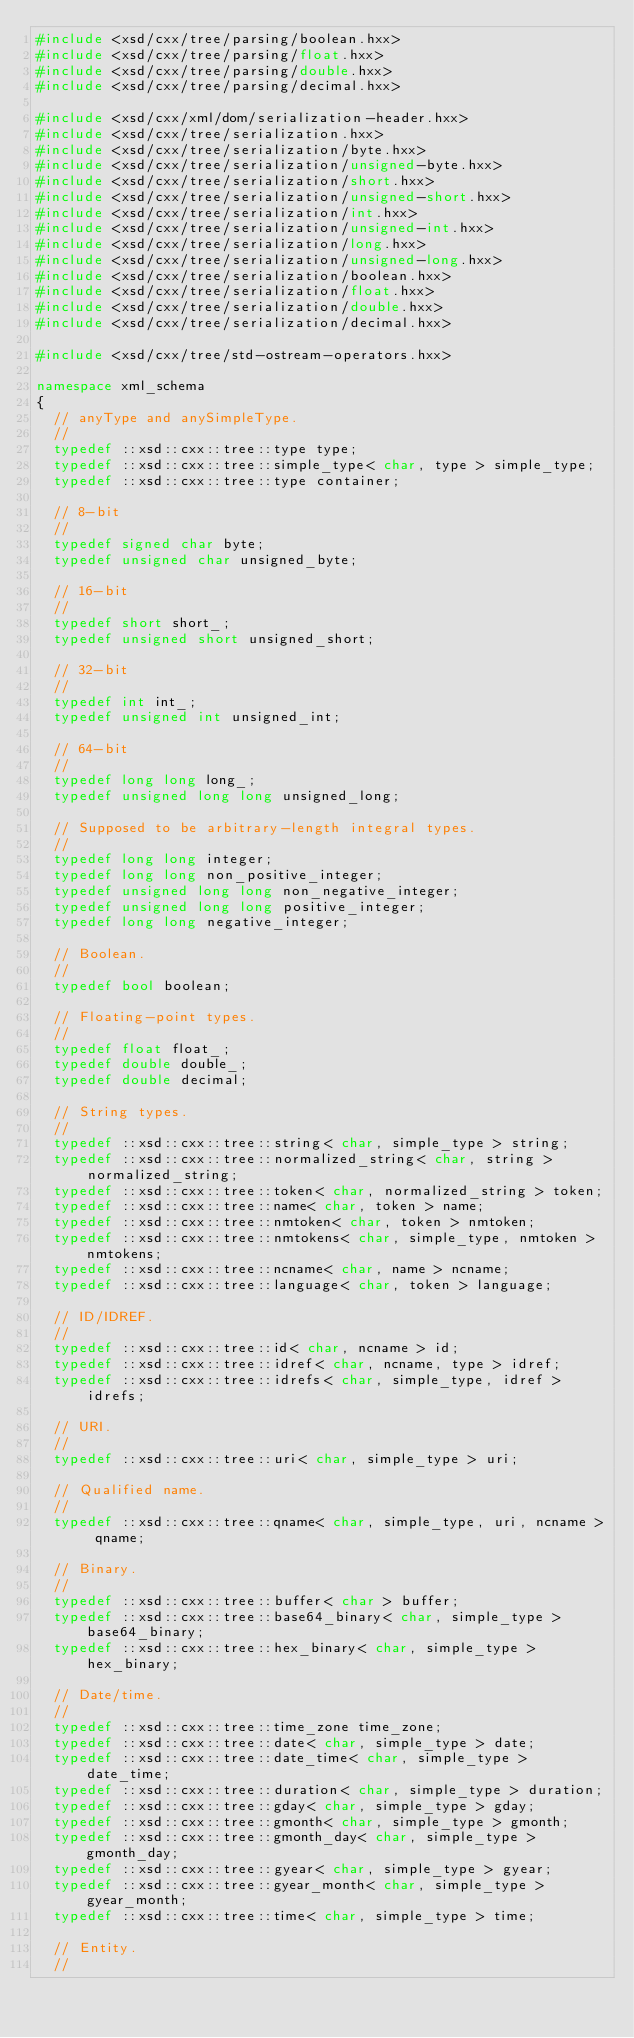Convert code to text. <code><loc_0><loc_0><loc_500><loc_500><_C++_>#include <xsd/cxx/tree/parsing/boolean.hxx>
#include <xsd/cxx/tree/parsing/float.hxx>
#include <xsd/cxx/tree/parsing/double.hxx>
#include <xsd/cxx/tree/parsing/decimal.hxx>

#include <xsd/cxx/xml/dom/serialization-header.hxx>
#include <xsd/cxx/tree/serialization.hxx>
#include <xsd/cxx/tree/serialization/byte.hxx>
#include <xsd/cxx/tree/serialization/unsigned-byte.hxx>
#include <xsd/cxx/tree/serialization/short.hxx>
#include <xsd/cxx/tree/serialization/unsigned-short.hxx>
#include <xsd/cxx/tree/serialization/int.hxx>
#include <xsd/cxx/tree/serialization/unsigned-int.hxx>
#include <xsd/cxx/tree/serialization/long.hxx>
#include <xsd/cxx/tree/serialization/unsigned-long.hxx>
#include <xsd/cxx/tree/serialization/boolean.hxx>
#include <xsd/cxx/tree/serialization/float.hxx>
#include <xsd/cxx/tree/serialization/double.hxx>
#include <xsd/cxx/tree/serialization/decimal.hxx>

#include <xsd/cxx/tree/std-ostream-operators.hxx>

namespace xml_schema
{
  // anyType and anySimpleType.
  //
  typedef ::xsd::cxx::tree::type type;
  typedef ::xsd::cxx::tree::simple_type< char, type > simple_type;
  typedef ::xsd::cxx::tree::type container;

  // 8-bit
  //
  typedef signed char byte;
  typedef unsigned char unsigned_byte;

  // 16-bit
  //
  typedef short short_;
  typedef unsigned short unsigned_short;

  // 32-bit
  //
  typedef int int_;
  typedef unsigned int unsigned_int;

  // 64-bit
  //
  typedef long long long_;
  typedef unsigned long long unsigned_long;

  // Supposed to be arbitrary-length integral types.
  //
  typedef long long integer;
  typedef long long non_positive_integer;
  typedef unsigned long long non_negative_integer;
  typedef unsigned long long positive_integer;
  typedef long long negative_integer;

  // Boolean.
  //
  typedef bool boolean;

  // Floating-point types.
  //
  typedef float float_;
  typedef double double_;
  typedef double decimal;

  // String types.
  //
  typedef ::xsd::cxx::tree::string< char, simple_type > string;
  typedef ::xsd::cxx::tree::normalized_string< char, string > normalized_string;
  typedef ::xsd::cxx::tree::token< char, normalized_string > token;
  typedef ::xsd::cxx::tree::name< char, token > name;
  typedef ::xsd::cxx::tree::nmtoken< char, token > nmtoken;
  typedef ::xsd::cxx::tree::nmtokens< char, simple_type, nmtoken > nmtokens;
  typedef ::xsd::cxx::tree::ncname< char, name > ncname;
  typedef ::xsd::cxx::tree::language< char, token > language;

  // ID/IDREF.
  //
  typedef ::xsd::cxx::tree::id< char, ncname > id;
  typedef ::xsd::cxx::tree::idref< char, ncname, type > idref;
  typedef ::xsd::cxx::tree::idrefs< char, simple_type, idref > idrefs;

  // URI.
  //
  typedef ::xsd::cxx::tree::uri< char, simple_type > uri;

  // Qualified name.
  //
  typedef ::xsd::cxx::tree::qname< char, simple_type, uri, ncname > qname;

  // Binary.
  //
  typedef ::xsd::cxx::tree::buffer< char > buffer;
  typedef ::xsd::cxx::tree::base64_binary< char, simple_type > base64_binary;
  typedef ::xsd::cxx::tree::hex_binary< char, simple_type > hex_binary;

  // Date/time.
  //
  typedef ::xsd::cxx::tree::time_zone time_zone;
  typedef ::xsd::cxx::tree::date< char, simple_type > date;
  typedef ::xsd::cxx::tree::date_time< char, simple_type > date_time;
  typedef ::xsd::cxx::tree::duration< char, simple_type > duration;
  typedef ::xsd::cxx::tree::gday< char, simple_type > gday;
  typedef ::xsd::cxx::tree::gmonth< char, simple_type > gmonth;
  typedef ::xsd::cxx::tree::gmonth_day< char, simple_type > gmonth_day;
  typedef ::xsd::cxx::tree::gyear< char, simple_type > gyear;
  typedef ::xsd::cxx::tree::gyear_month< char, simple_type > gyear_month;
  typedef ::xsd::cxx::tree::time< char, simple_type > time;

  // Entity.
  //</code> 